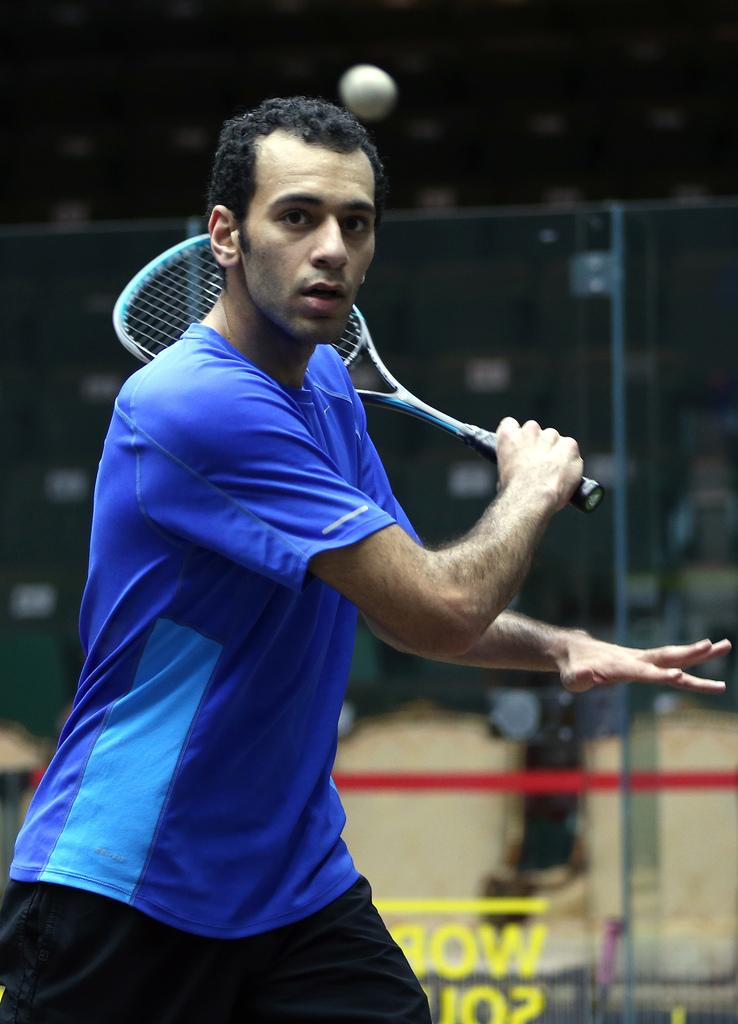Who is present in the image? There is a man in the picture. What is the man doing in the image? The man is standing in the image. What object is the man holding in his hand? The man is holding a tennis racket in his hand. What type of bead is the man using to play with in the image? There is no bead present in the image; the man is holding a tennis racket. Can you tell me where the cellar is located in the image? There is no mention of a cellar in the image; it features a man holding a tennis racket. 